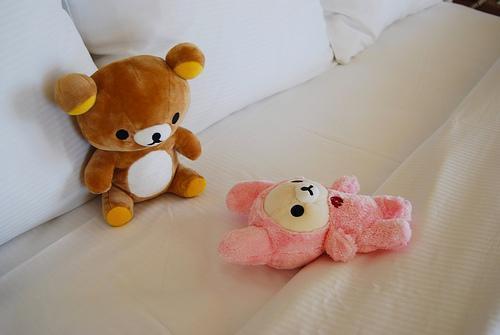How many dolls are there?
Give a very brief answer. 2. How many pillows are on the bed?
Give a very brief answer. 3. How many toys are there?
Give a very brief answer. 2. How many teddy bears are visible?
Give a very brief answer. 2. 